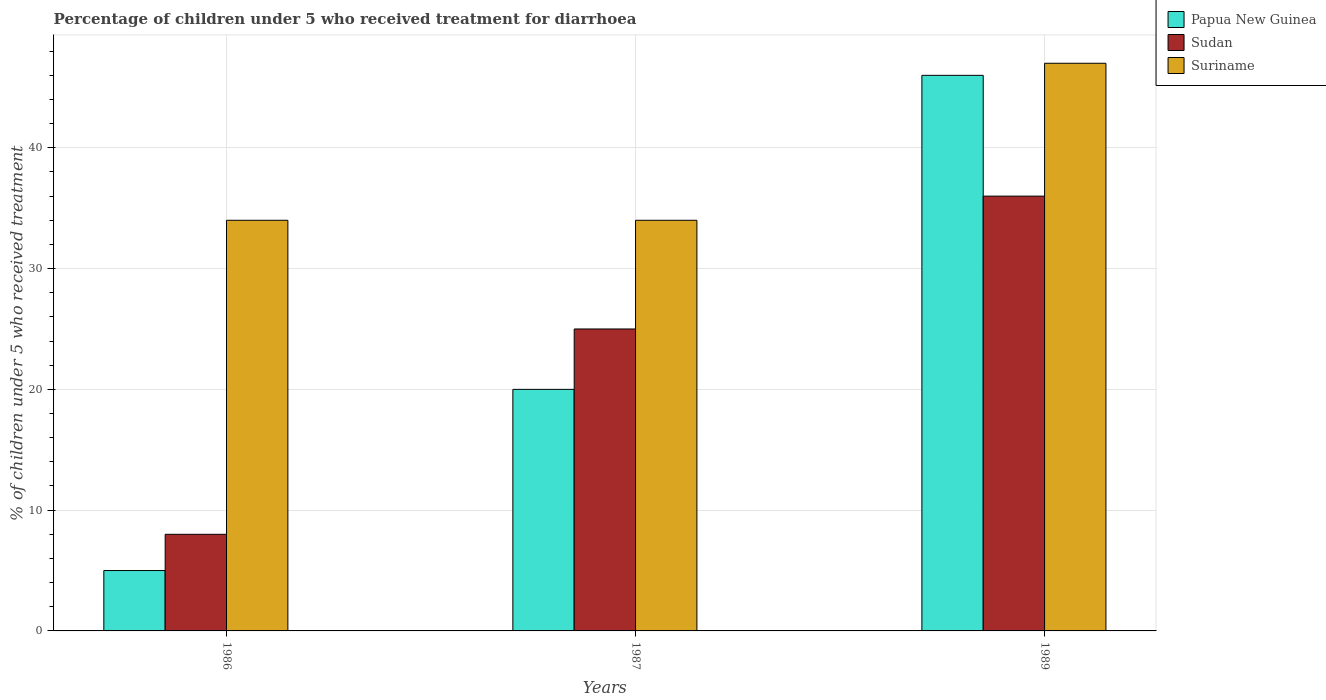How many groups of bars are there?
Offer a very short reply. 3. Are the number of bars per tick equal to the number of legend labels?
Offer a very short reply. Yes. How many bars are there on the 3rd tick from the left?
Make the answer very short. 3. How many bars are there on the 2nd tick from the right?
Ensure brevity in your answer.  3. What is the label of the 2nd group of bars from the left?
Your answer should be very brief. 1987. What is the percentage of children who received treatment for diarrhoea  in Papua New Guinea in 1987?
Provide a short and direct response. 20. Across all years, what is the minimum percentage of children who received treatment for diarrhoea  in Papua New Guinea?
Your answer should be compact. 5. In which year was the percentage of children who received treatment for diarrhoea  in Suriname maximum?
Your answer should be compact. 1989. What is the total percentage of children who received treatment for diarrhoea  in Suriname in the graph?
Give a very brief answer. 115. What is the difference between the percentage of children who received treatment for diarrhoea  in Papua New Guinea in 1987 and that in 1989?
Provide a short and direct response. -26. What is the difference between the percentage of children who received treatment for diarrhoea  in Sudan in 1986 and the percentage of children who received treatment for diarrhoea  in Suriname in 1987?
Your answer should be very brief. -26. What is the average percentage of children who received treatment for diarrhoea  in Sudan per year?
Offer a very short reply. 23. What is the ratio of the percentage of children who received treatment for diarrhoea  in Sudan in 1986 to that in 1989?
Your response must be concise. 0.22. Is the percentage of children who received treatment for diarrhoea  in Suriname in 1987 less than that in 1989?
Make the answer very short. Yes. Is the difference between the percentage of children who received treatment for diarrhoea  in Sudan in 1987 and 1989 greater than the difference between the percentage of children who received treatment for diarrhoea  in Papua New Guinea in 1987 and 1989?
Your response must be concise. Yes. What does the 3rd bar from the left in 1986 represents?
Your answer should be compact. Suriname. What does the 2nd bar from the right in 1987 represents?
Offer a terse response. Sudan. Are all the bars in the graph horizontal?
Make the answer very short. No. How many years are there in the graph?
Your answer should be very brief. 3. What is the difference between two consecutive major ticks on the Y-axis?
Offer a very short reply. 10. Are the values on the major ticks of Y-axis written in scientific E-notation?
Keep it short and to the point. No. Where does the legend appear in the graph?
Your answer should be very brief. Top right. How are the legend labels stacked?
Give a very brief answer. Vertical. What is the title of the graph?
Provide a succinct answer. Percentage of children under 5 who received treatment for diarrhoea. Does "Sub-Saharan Africa (all income levels)" appear as one of the legend labels in the graph?
Keep it short and to the point. No. What is the label or title of the Y-axis?
Make the answer very short. % of children under 5 who received treatment. What is the % of children under 5 who received treatment of Suriname in 1986?
Make the answer very short. 34. What is the % of children under 5 who received treatment of Papua New Guinea in 1987?
Ensure brevity in your answer.  20. What is the % of children under 5 who received treatment of Suriname in 1989?
Keep it short and to the point. 47. Across all years, what is the maximum % of children under 5 who received treatment of Suriname?
Your answer should be very brief. 47. Across all years, what is the minimum % of children under 5 who received treatment of Sudan?
Provide a short and direct response. 8. What is the total % of children under 5 who received treatment in Papua New Guinea in the graph?
Ensure brevity in your answer.  71. What is the total % of children under 5 who received treatment of Suriname in the graph?
Offer a terse response. 115. What is the difference between the % of children under 5 who received treatment in Papua New Guinea in 1986 and that in 1989?
Offer a very short reply. -41. What is the difference between the % of children under 5 who received treatment in Sudan in 1986 and that in 1989?
Provide a short and direct response. -28. What is the difference between the % of children under 5 who received treatment in Sudan in 1987 and that in 1989?
Your answer should be compact. -11. What is the difference between the % of children under 5 who received treatment of Suriname in 1987 and that in 1989?
Provide a succinct answer. -13. What is the difference between the % of children under 5 who received treatment in Papua New Guinea in 1986 and the % of children under 5 who received treatment in Sudan in 1987?
Offer a very short reply. -20. What is the difference between the % of children under 5 who received treatment of Papua New Guinea in 1986 and the % of children under 5 who received treatment of Suriname in 1987?
Ensure brevity in your answer.  -29. What is the difference between the % of children under 5 who received treatment of Sudan in 1986 and the % of children under 5 who received treatment of Suriname in 1987?
Offer a very short reply. -26. What is the difference between the % of children under 5 who received treatment in Papua New Guinea in 1986 and the % of children under 5 who received treatment in Sudan in 1989?
Keep it short and to the point. -31. What is the difference between the % of children under 5 who received treatment in Papua New Guinea in 1986 and the % of children under 5 who received treatment in Suriname in 1989?
Offer a terse response. -42. What is the difference between the % of children under 5 who received treatment in Sudan in 1986 and the % of children under 5 who received treatment in Suriname in 1989?
Offer a terse response. -39. What is the difference between the % of children under 5 who received treatment of Papua New Guinea in 1987 and the % of children under 5 who received treatment of Sudan in 1989?
Offer a very short reply. -16. What is the average % of children under 5 who received treatment of Papua New Guinea per year?
Your answer should be very brief. 23.67. What is the average % of children under 5 who received treatment of Sudan per year?
Ensure brevity in your answer.  23. What is the average % of children under 5 who received treatment in Suriname per year?
Your answer should be compact. 38.33. In the year 1986, what is the difference between the % of children under 5 who received treatment of Papua New Guinea and % of children under 5 who received treatment of Sudan?
Give a very brief answer. -3. In the year 1986, what is the difference between the % of children under 5 who received treatment of Papua New Guinea and % of children under 5 who received treatment of Suriname?
Ensure brevity in your answer.  -29. In the year 1987, what is the difference between the % of children under 5 who received treatment in Papua New Guinea and % of children under 5 who received treatment in Sudan?
Give a very brief answer. -5. In the year 1987, what is the difference between the % of children under 5 who received treatment in Papua New Guinea and % of children under 5 who received treatment in Suriname?
Ensure brevity in your answer.  -14. In the year 1987, what is the difference between the % of children under 5 who received treatment in Sudan and % of children under 5 who received treatment in Suriname?
Offer a very short reply. -9. In the year 1989, what is the difference between the % of children under 5 who received treatment of Papua New Guinea and % of children under 5 who received treatment of Sudan?
Your answer should be compact. 10. In the year 1989, what is the difference between the % of children under 5 who received treatment of Papua New Guinea and % of children under 5 who received treatment of Suriname?
Provide a short and direct response. -1. In the year 1989, what is the difference between the % of children under 5 who received treatment in Sudan and % of children under 5 who received treatment in Suriname?
Offer a terse response. -11. What is the ratio of the % of children under 5 who received treatment in Papua New Guinea in 1986 to that in 1987?
Provide a succinct answer. 0.25. What is the ratio of the % of children under 5 who received treatment of Sudan in 1986 to that in 1987?
Offer a very short reply. 0.32. What is the ratio of the % of children under 5 who received treatment of Suriname in 1986 to that in 1987?
Ensure brevity in your answer.  1. What is the ratio of the % of children under 5 who received treatment of Papua New Guinea in 1986 to that in 1989?
Give a very brief answer. 0.11. What is the ratio of the % of children under 5 who received treatment in Sudan in 1986 to that in 1989?
Give a very brief answer. 0.22. What is the ratio of the % of children under 5 who received treatment in Suriname in 1986 to that in 1989?
Ensure brevity in your answer.  0.72. What is the ratio of the % of children under 5 who received treatment of Papua New Guinea in 1987 to that in 1989?
Provide a succinct answer. 0.43. What is the ratio of the % of children under 5 who received treatment in Sudan in 1987 to that in 1989?
Give a very brief answer. 0.69. What is the ratio of the % of children under 5 who received treatment in Suriname in 1987 to that in 1989?
Your response must be concise. 0.72. What is the difference between the highest and the second highest % of children under 5 who received treatment in Sudan?
Keep it short and to the point. 11. What is the difference between the highest and the lowest % of children under 5 who received treatment in Suriname?
Your response must be concise. 13. 